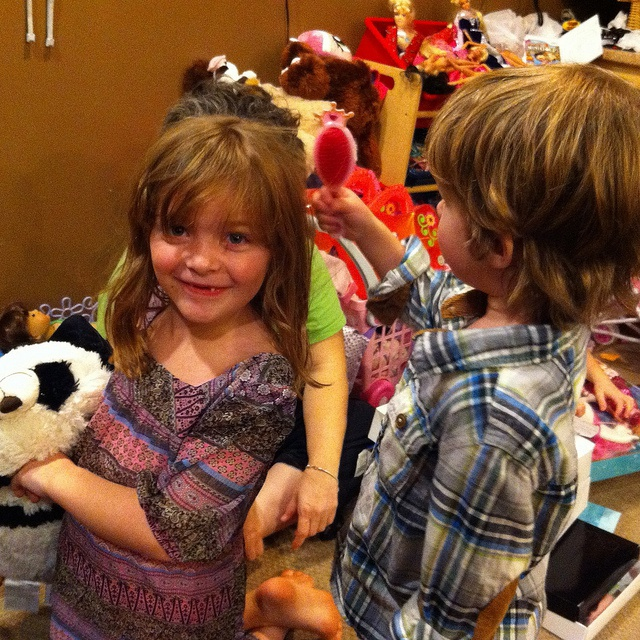Describe the objects in this image and their specific colors. I can see people in olive, black, maroon, and gray tones, people in olive, maroon, black, and brown tones, people in olive, orange, black, maroon, and brown tones, teddy bear in olive, black, ivory, gray, and tan tones, and teddy bear in olive, maroon, black, tan, and khaki tones in this image. 